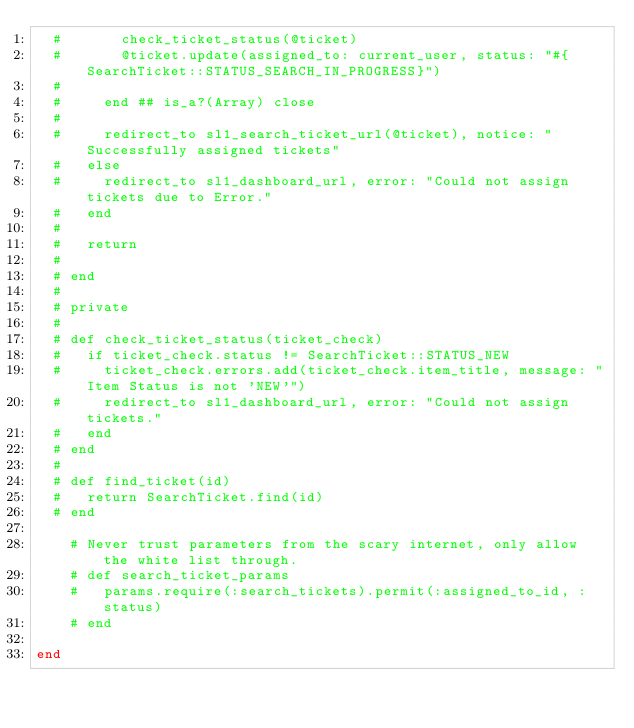Convert code to text. <code><loc_0><loc_0><loc_500><loc_500><_Ruby_>  #       check_ticket_status(@ticket)
  #       @ticket.update(assigned_to: current_user, status: "#{SearchTicket::STATUS_SEARCH_IN_PROGRESS}")
  #
  #     end ## is_a?(Array) close
  #
  #     redirect_to sl1_search_ticket_url(@ticket), notice: "Successfully assigned tickets"
  #   else
  #     redirect_to sl1_dashboard_url, error: "Could not assign tickets due to Error."
  #   end
  #
  #   return
  #
  # end
  #
  # private
  #
  # def check_ticket_status(ticket_check)
  #   if ticket_check.status != SearchTicket::STATUS_NEW
  #     ticket_check.errors.add(ticket_check.item_title, message: "Item Status is not 'NEW'")
  #     redirect_to sl1_dashboard_url, error: "Could not assign tickets."
  #   end
  # end
  #
  # def find_ticket(id)
  #   return SearchTicket.find(id)
  # end

    # Never trust parameters from the scary internet, only allow the white list through.
    # def search_ticket_params
    #   params.require(:search_tickets).permit(:assigned_to_id, :status)
    # end

end
</code> 